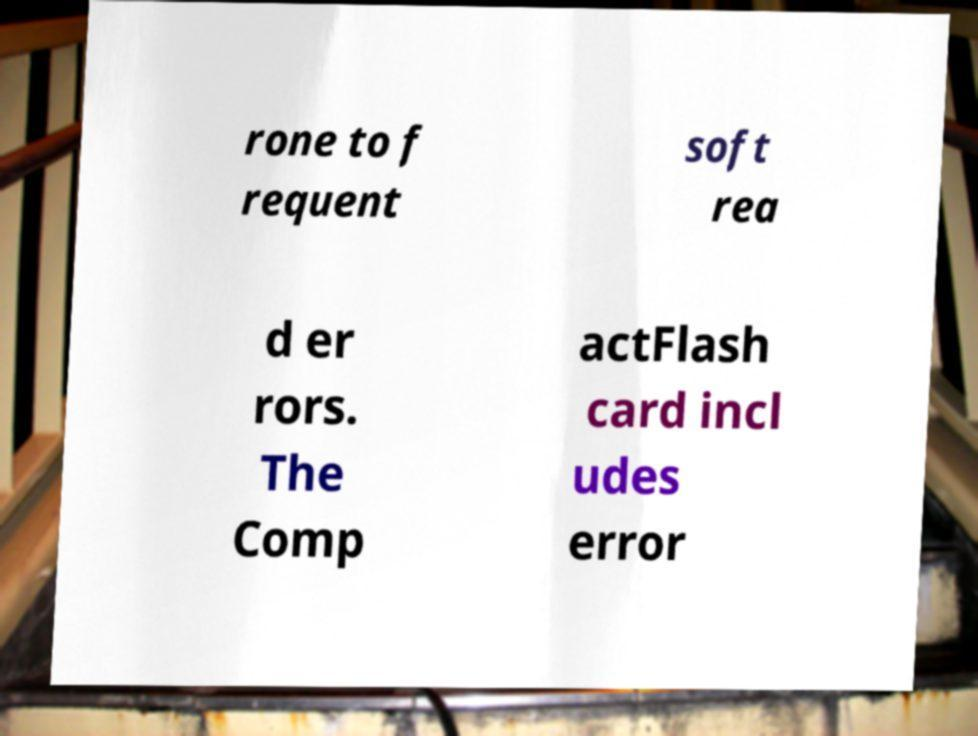I need the written content from this picture converted into text. Can you do that? rone to f requent soft rea d er rors. The Comp actFlash card incl udes error 